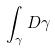Convert formula to latex. <formula><loc_0><loc_0><loc_500><loc_500>\int _ { \gamma } D \gamma</formula> 